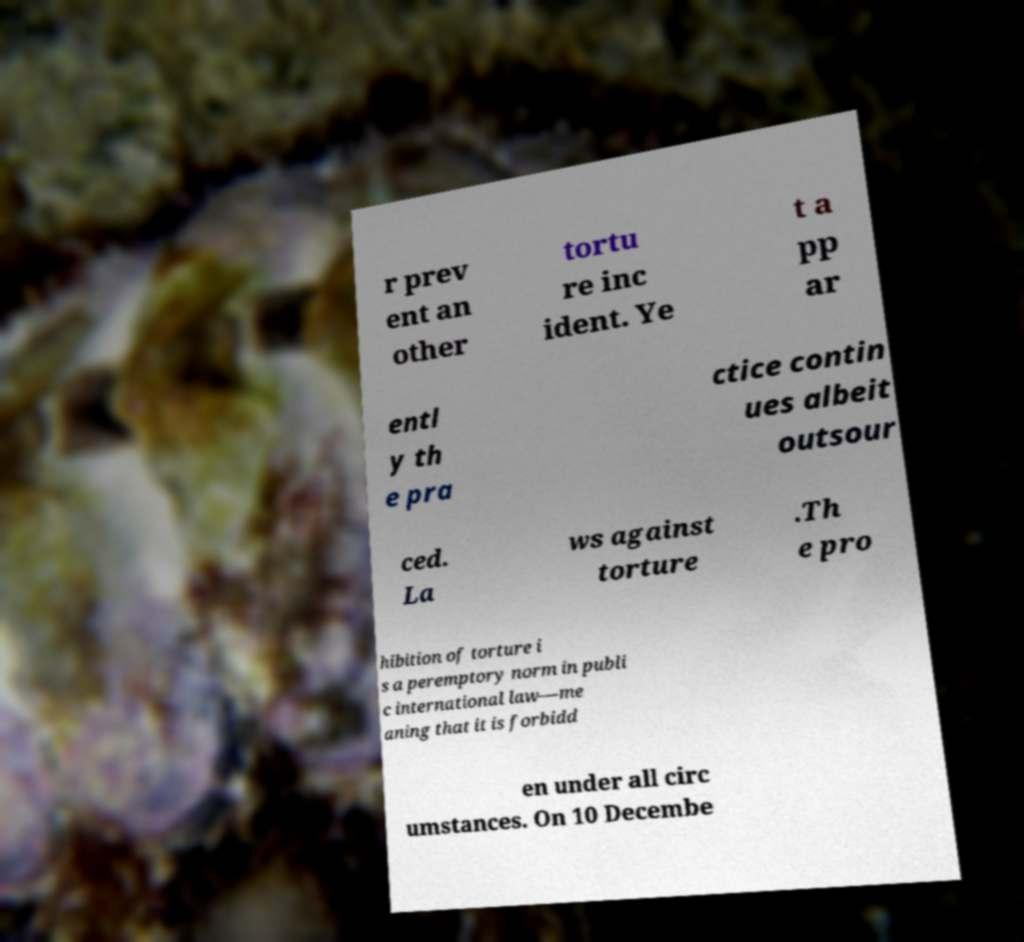Can you accurately transcribe the text from the provided image for me? r prev ent an other tortu re inc ident. Ye t a pp ar entl y th e pra ctice contin ues albeit outsour ced. La ws against torture .Th e pro hibition of torture i s a peremptory norm in publi c international law—me aning that it is forbidd en under all circ umstances. On 10 Decembe 